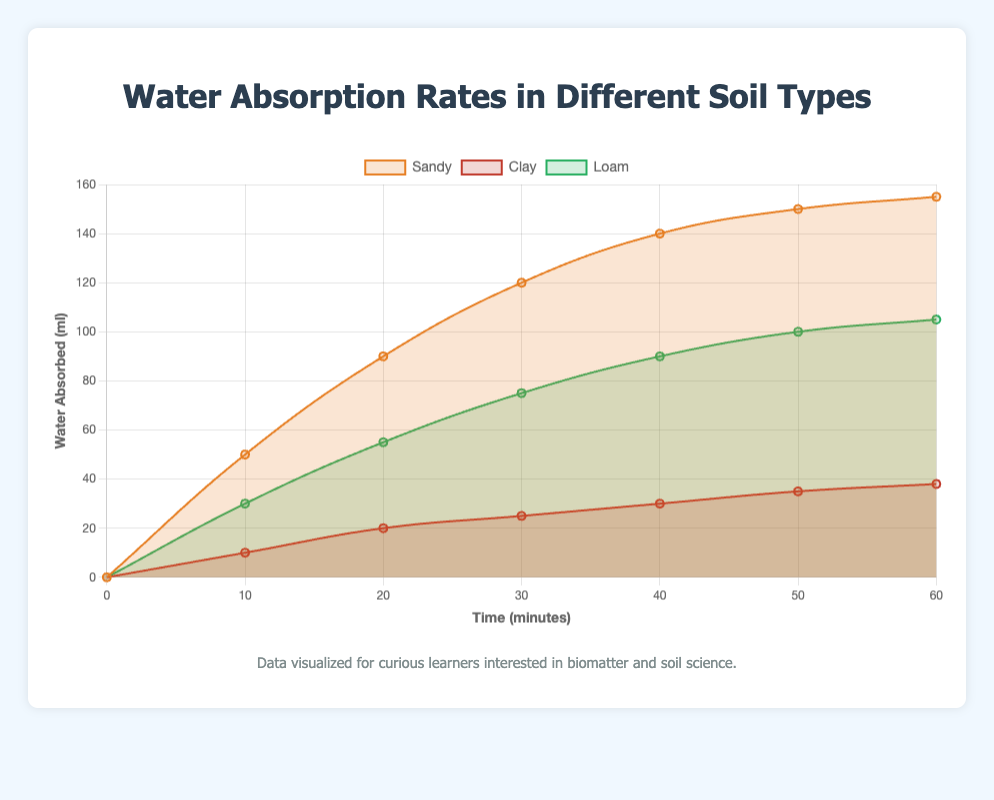What is the water absorption rate of sandy soil after 20 minutes? The figure shows the absorption rate of sandy soil at each time interval. According to the plot, sandy soil absorbs 90 ml of water after 20 minutes.
Answer: 90 ml Which soil type absorbs the most water after 60 minutes? To determine which soil type absorbs the most water, refer to the end points of each curve. Sandy soil absorbs 155 ml, clay absorbs 38 ml, and loam absorbs 105 ml. Sandy soil absorbs the most water.
Answer: Sandy Which soil type absorbs water the slowest over the 60-minute period? By observing the slopes of the curves, the clay soil curve increases the slowest compared to sandy and loam soil, indicating it absorbs water the slowest.
Answer: Clay What is the difference in water absorption between loam and clay soil after 40 minutes? From the plot, loam soil absorbs 90 ml and clay soil absorbs 30 ml after 40 minutes. The difference is 90 - 30 = 60 ml.
Answer: 60 ml What is the average water absorption rate of loam soil over the 60-minute period? Sum up the water absorbed by loam soil at each time point (0+30+55+75+90+100+105 = 455 ml) and divide by the number of time points (7). The average rate is 455/7 ≈ 65 ml.
Answer: 65 ml Which soil type shows the steepest initial increase in water absorption? The steepness is indicated by the slope of the curve. Sandy soil shows the steepest initial increase since its absorption rate rises sharply within the first 10 minutes.
Answer: Sandy By what factor does the water absorption of sandy soil at 60 minutes exceed that of clay soil at the same time? Sandy soil absorbs 155 ml and clay absorbs 38 ml at 60 minutes. The factor is 155/38 ≈ 4.1.
Answer: 4.1 At what time do sandy and loam soils absorb approximately the same amount of water? Find the point where the two curves intersect or are closest to each other. Both soils absorb around 75 ml at approximately 30 minutes.
Answer: 30 minutes How much more water does sandy soil absorb compared to loam soil at the 50-minute mark? From the plot, sandy soil absorbs 150 ml and loam soil absorbs 100 ml at 50 minutes. The difference is 150 - 100 = 50 ml.
Answer: 50 ml Is the rate of water absorption of clay soil steady over time? The clay soil curve shows a relatively steady and gradual increase, indicating a consistent rate of absorption compared to the more variable rates of sandy and loam soils.
Answer: Yes 